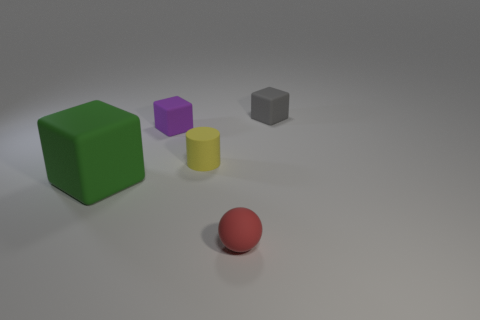Add 1 blue cylinders. How many objects exist? 6 Subtract all green cubes. How many cubes are left? 2 Subtract all tiny rubber cubes. How many cubes are left? 1 Subtract all cylinders. How many objects are left? 4 Subtract all red blocks. Subtract all blue balls. How many blocks are left? 3 Subtract all green cubes. How many yellow balls are left? 0 Subtract all red matte spheres. Subtract all small red matte things. How many objects are left? 3 Add 2 matte spheres. How many matte spheres are left? 3 Add 3 large green things. How many large green things exist? 4 Subtract 1 yellow cylinders. How many objects are left? 4 